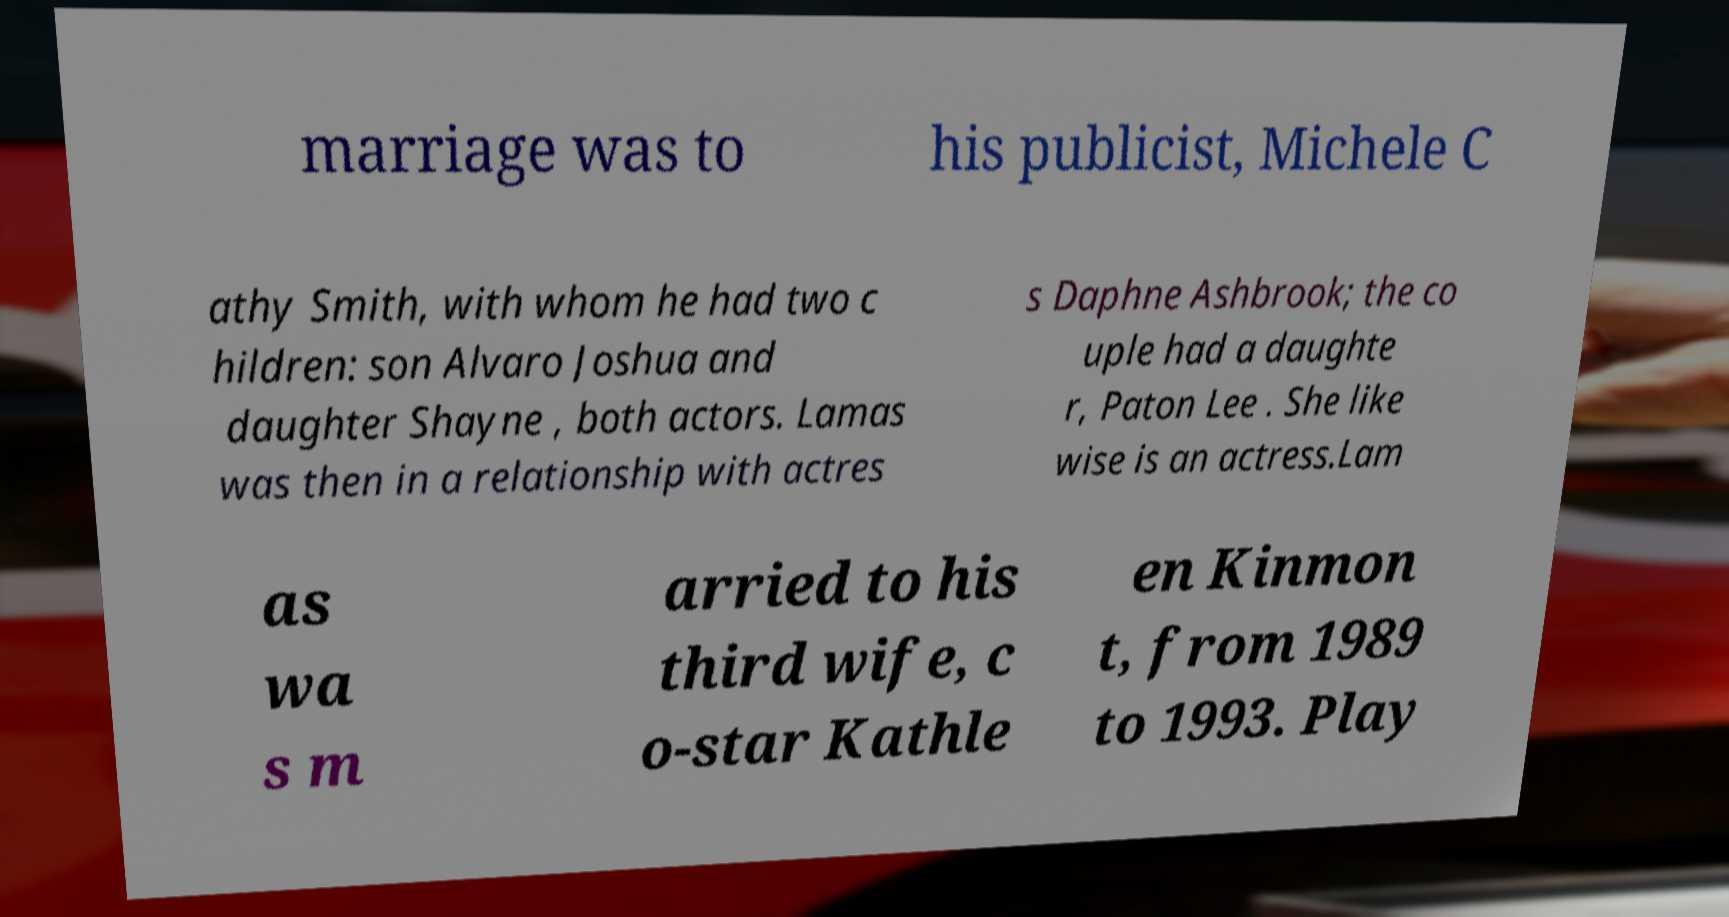Can you read and provide the text displayed in the image?This photo seems to have some interesting text. Can you extract and type it out for me? marriage was to his publicist, Michele C athy Smith, with whom he had two c hildren: son Alvaro Joshua and daughter Shayne , both actors. Lamas was then in a relationship with actres s Daphne Ashbrook; the co uple had a daughte r, Paton Lee . She like wise is an actress.Lam as wa s m arried to his third wife, c o-star Kathle en Kinmon t, from 1989 to 1993. Play 